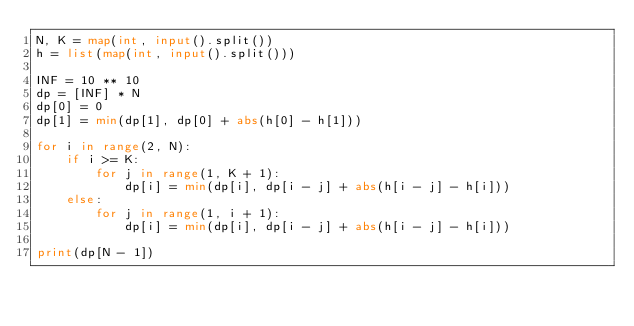Convert code to text. <code><loc_0><loc_0><loc_500><loc_500><_Python_>N, K = map(int, input().split())
h = list(map(int, input().split()))

INF = 10 ** 10
dp = [INF] * N
dp[0] = 0
dp[1] = min(dp[1], dp[0] + abs(h[0] - h[1]))

for i in range(2, N):
    if i >= K:
        for j in range(1, K + 1):
            dp[i] = min(dp[i], dp[i - j] + abs(h[i - j] - h[i]))
    else:
        for j in range(1, i + 1):
            dp[i] = min(dp[i], dp[i - j] + abs(h[i - j] - h[i]))

print(dp[N - 1])
</code> 